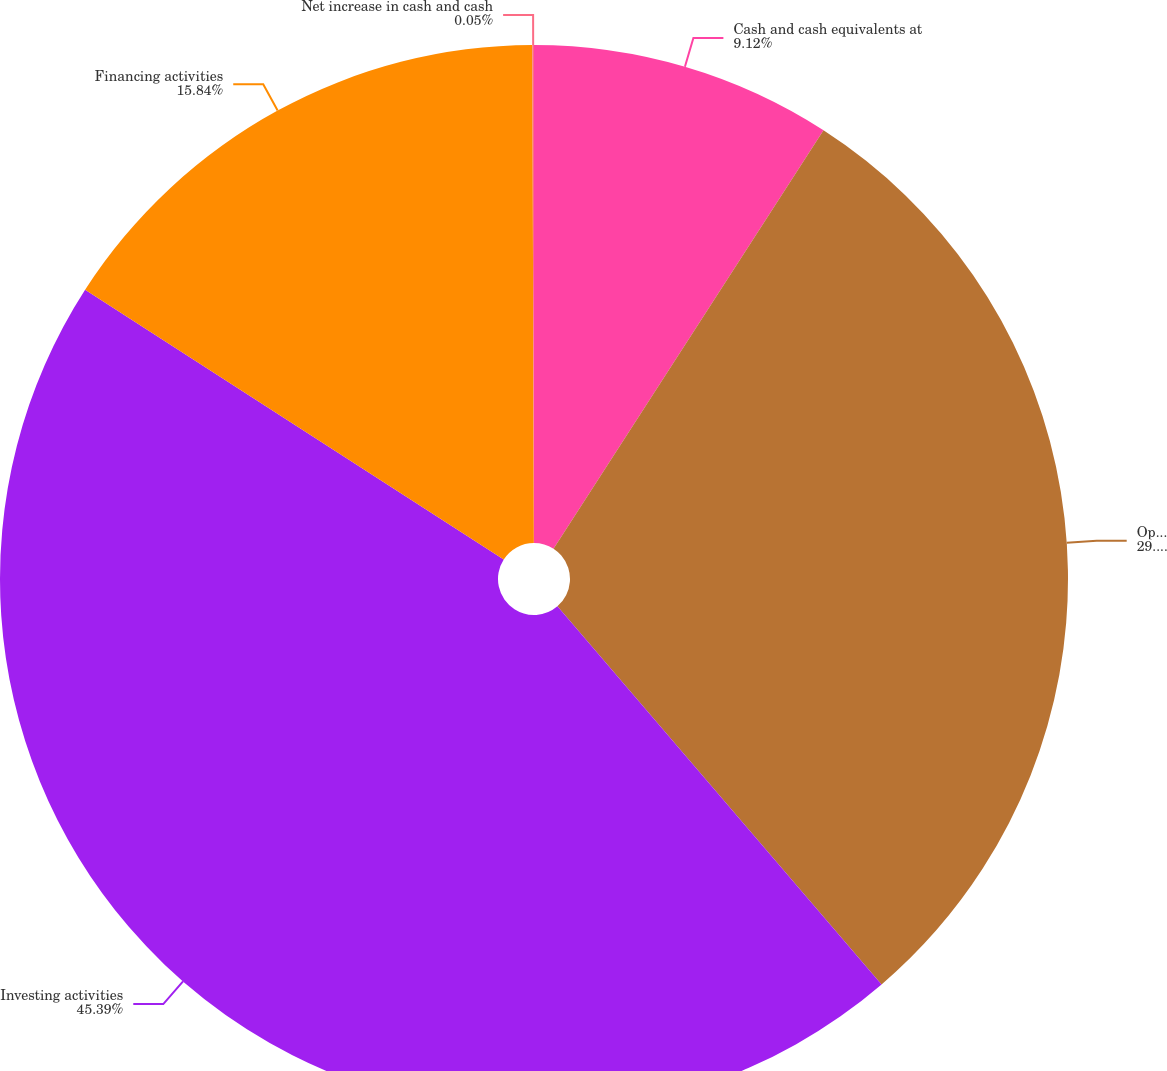Convert chart. <chart><loc_0><loc_0><loc_500><loc_500><pie_chart><fcel>Cash and cash equivalents at<fcel>Operating activities<fcel>Investing activities<fcel>Financing activities<fcel>Net increase in cash and cash<nl><fcel>9.12%<fcel>29.6%<fcel>45.39%<fcel>15.84%<fcel>0.05%<nl></chart> 